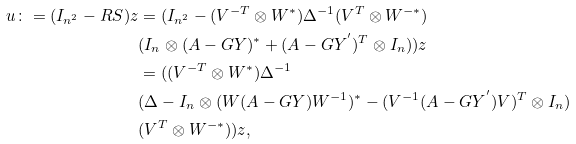<formula> <loc_0><loc_0><loc_500><loc_500>u \colon = ( I _ { n ^ { 2 } } - R S ) z & = ( I _ { n ^ { 2 } } - ( V ^ { - T } \otimes W ^ { * } ) \Delta ^ { - 1 } ( V ^ { T } \otimes W ^ { - * } ) \\ & ( I _ { n } \otimes ( A - G Y ) ^ { * } + ( A - G Y ^ { ^ { \prime } } ) ^ { T } \otimes I _ { n } ) ) z \\ & = ( ( V ^ { - T } \otimes W ^ { * } ) \Delta ^ { - 1 } \\ & ( \Delta - I _ { n } \otimes ( W ( A - G Y ) W ^ { - 1 } ) ^ { * } - ( V ^ { - 1 } ( A - G Y ^ { ^ { \prime } } ) V ) ^ { T } \otimes I _ { n } ) \\ & ( V ^ { T } \otimes W ^ { - * } ) ) z ,</formula> 